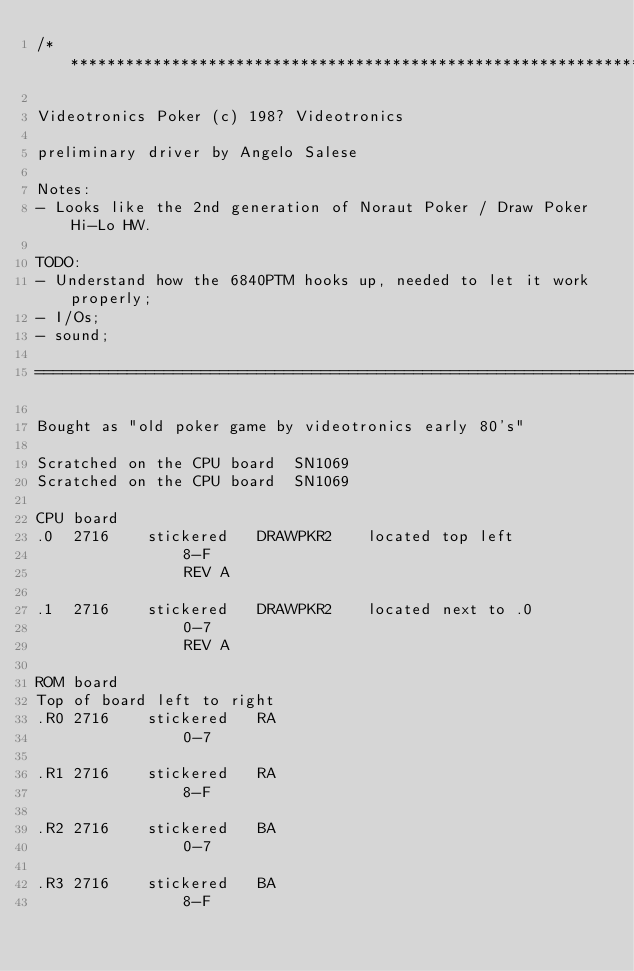<code> <loc_0><loc_0><loc_500><loc_500><_C_>/**************************************************************************************************************

Videotronics Poker (c) 198? Videotronics

preliminary driver by Angelo Salese

Notes:
- Looks like the 2nd generation of Noraut Poker / Draw Poker Hi-Lo HW.

TODO:
- Understand how the 6840PTM hooks up, needed to let it work properly;
- I/Os;
- sound;

===============================================================================================================

Bought as "old poker game by videotronics early 80's"

Scratched on the CPU board  SN1069
Scratched on the CPU board  SN1069

CPU board
.0  2716    stickered   DRAWPKR2    located top left
                8-F
                REV A

.1  2716    stickered   DRAWPKR2    located next to .0
                0-7
                REV A

ROM board
Top of board left to right
.R0 2716    stickered   RA
                0-7

.R1 2716    stickered   RA
                8-F

.R2 2716    stickered   BA
                0-7

.R3 2716    stickered   BA
                8-F
</code> 